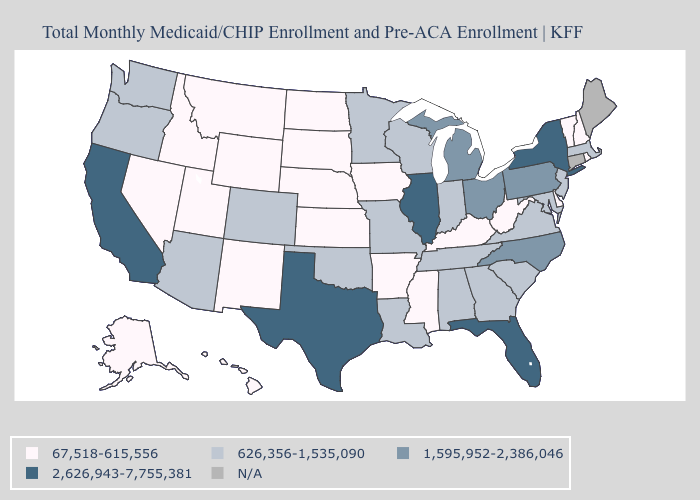What is the value of Wisconsin?
Be succinct. 626,356-1,535,090. Name the states that have a value in the range 67,518-615,556?
Concise answer only. Alaska, Arkansas, Delaware, Hawaii, Idaho, Iowa, Kansas, Kentucky, Mississippi, Montana, Nebraska, Nevada, New Hampshire, New Mexico, North Dakota, Rhode Island, South Dakota, Utah, Vermont, West Virginia, Wyoming. Among the states that border New Mexico , does Colorado have the highest value?
Give a very brief answer. No. Is the legend a continuous bar?
Answer briefly. No. What is the highest value in states that border Georgia?
Keep it brief. 2,626,943-7,755,381. What is the value of Nebraska?
Be succinct. 67,518-615,556. Which states have the lowest value in the West?
Write a very short answer. Alaska, Hawaii, Idaho, Montana, Nevada, New Mexico, Utah, Wyoming. Which states have the lowest value in the West?
Short answer required. Alaska, Hawaii, Idaho, Montana, Nevada, New Mexico, Utah, Wyoming. Name the states that have a value in the range 1,595,952-2,386,046?
Keep it brief. Michigan, North Carolina, Ohio, Pennsylvania. Name the states that have a value in the range 2,626,943-7,755,381?
Short answer required. California, Florida, Illinois, New York, Texas. Name the states that have a value in the range N/A?
Answer briefly. Connecticut, Maine. Which states hav the highest value in the MidWest?
Write a very short answer. Illinois. What is the value of Wyoming?
Be succinct. 67,518-615,556. 